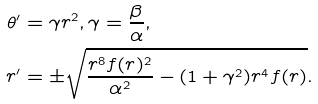<formula> <loc_0><loc_0><loc_500><loc_500>\theta ^ { \prime } & = \gamma r ^ { 2 } , \gamma = \frac { \beta } { \alpha } , \\ r ^ { \prime } & = \pm \sqrt { \frac { r ^ { 8 } f ( r ) ^ { 2 } } { \alpha ^ { 2 } } - ( 1 + \gamma ^ { 2 } ) r ^ { 4 } f ( r ) } .</formula> 